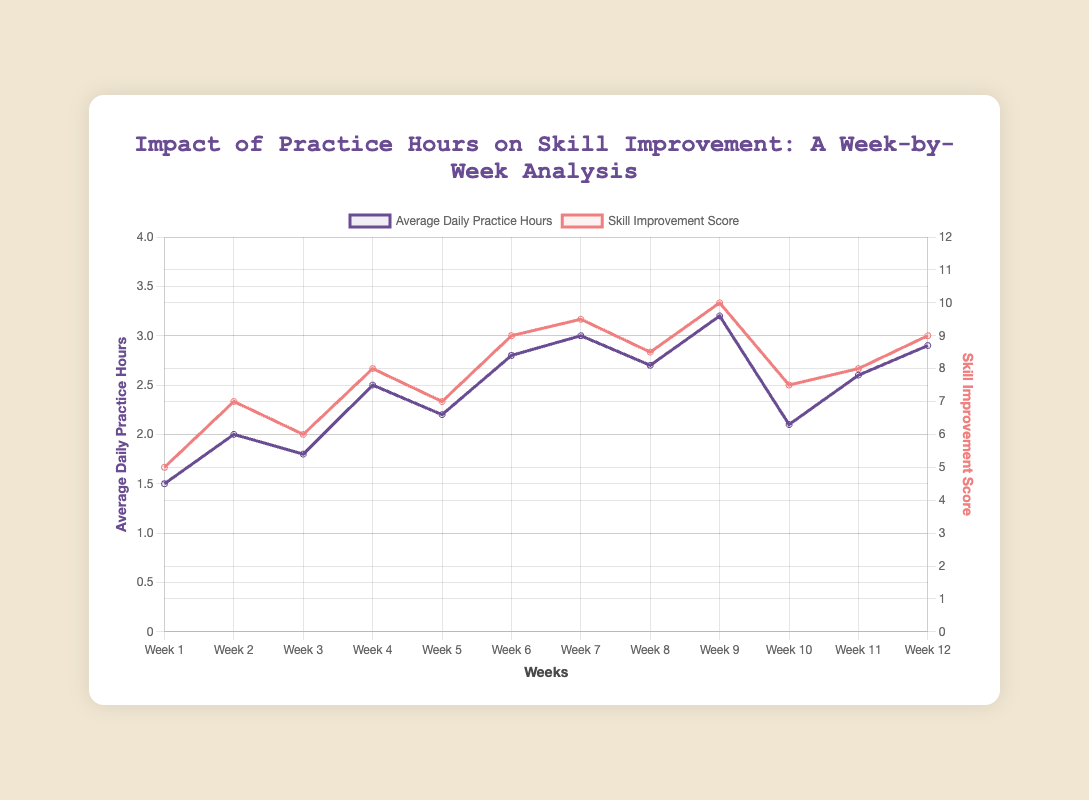What happens to the skill improvement score when average daily practice hours increase from 2.2 to 2.8 hours (Week 5 to Week 6)? By observing the trend from Week 5 to Week 6, we see an increase in skill improvement score from 7 to 9 as practice hours increase from 2.2 to 2.8
Answer: Skill improvement score increases How does the skill improvement score in Week 12 compare to Week 7? In Week 12, the skill improvement score is 9. In Week 7, it is 9.5. So, the score in Week 12 is slightly lower than in Week 7
Answer: Slightly lower What is the difference in average daily practice hours between Week 1 and Week 9? The average daily practice hours for Week 1 is 1.5 hours, and for Week 9, it is 3.2 hours. The difference is 3.2 - 1.5 = 1.7 hours
Answer: 1.7 hours Visualize the trend in skill improvement scores across the weeks. What week shows the first significant rise in skill improvement score? Plotting the skill improvement scores over the weeks, the first significant jump appears from Week 1 (5) to Week 2 (7)
Answer: Week 2 On which axis (left or right) is the skill improvement score plotted, and what is its color? The skill improvement score is plotted on the right axis, and it is colored red
Answer: Right axis, red What is the average skill improvement score from Week 6 to Week 9? Adding the scores from Week 6 (9), Week 7 (9.5), Week 8 (8.5), and Week 9 (10) and then dividing by 4, get (9 + 9.5 + 8.5 + 10)/4 = 37/4 = 9.25
Answer: 9.25 Compare the practice hours and skill improvement scores for the weeks with the highest and lowest practice hours. The week with the highest practice hours is Week 9 (3.2 hours) with a skill improvement score of 10. The week with the lowest is Week 1 (1.5 hours) with a skill improvement score of 5
Answer: Week 9: 3.2 hours, 10; Week 1: 1.5 hours, 5 How does the skill improvement score in Week 10 differ from the previous weeks, and what might explain this change? Week 10 shows a decrease in skill improvement score to 7.5 from Week 9’s peak of 10. The notes indicate external commitments, which might have reduced practice quality and frequency
Answer: Lower due to external commitments Which week shows the highest skill improvement score, and how many practice hours were logged on average daily that week? Week 9 shows the highest skill improvement score at 10 with an average daily practice of 3.2 hours
Answer: Week 9, 3.2 hours From Week 3 to Week 4, what change is observed in both practice hours and skill improvement scores? Practice hours increase from 1.8 to 2.5 and the skill improvement score increases from 6 to 8
Answer: Both increase 